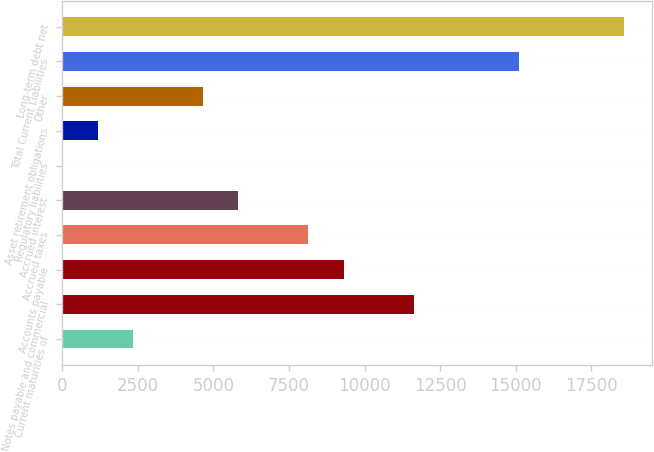Convert chart to OTSL. <chart><loc_0><loc_0><loc_500><loc_500><bar_chart><fcel>Current maturities of<fcel>Notes payable and commercial<fcel>Accounts payable<fcel>Accrued taxes<fcel>Accrued interest<fcel>Regulatory liabilities<fcel>Asset retirement obligations<fcel>Other<fcel>Total Current Liabilities<fcel>Long-term debt net<nl><fcel>2334.16<fcel>11624.4<fcel>9301.84<fcel>8140.56<fcel>5818<fcel>11.6<fcel>1172.88<fcel>4656.72<fcel>15108.2<fcel>18592.1<nl></chart> 